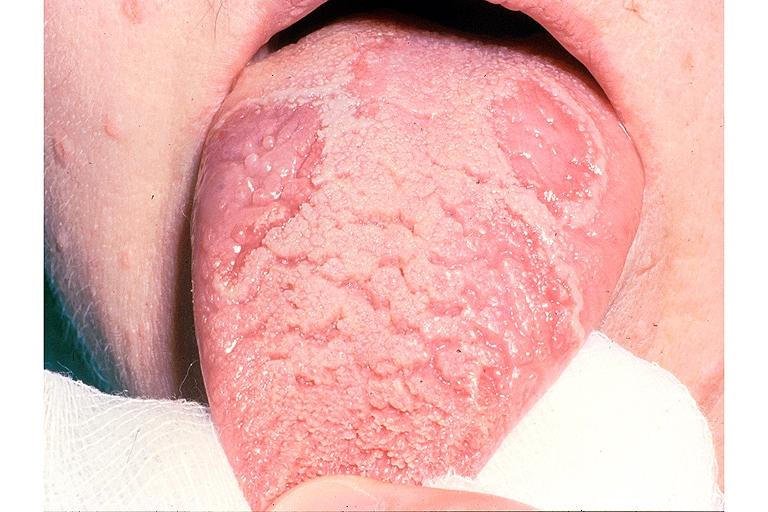does this image show benign migratory glossitis and fissured tongue?
Answer the question using a single word or phrase. Yes 